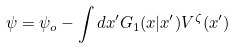<formula> <loc_0><loc_0><loc_500><loc_500>\psi = \psi _ { o } - \int d x ^ { \prime } G _ { 1 } ( x | x ^ { \prime } ) V ^ { \zeta } ( x ^ { \prime } )</formula> 